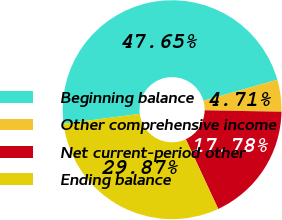Convert chart. <chart><loc_0><loc_0><loc_500><loc_500><pie_chart><fcel>Beginning balance<fcel>Other comprehensive income<fcel>Net current-period other<fcel>Ending balance<nl><fcel>47.65%<fcel>4.71%<fcel>17.78%<fcel>29.87%<nl></chart> 